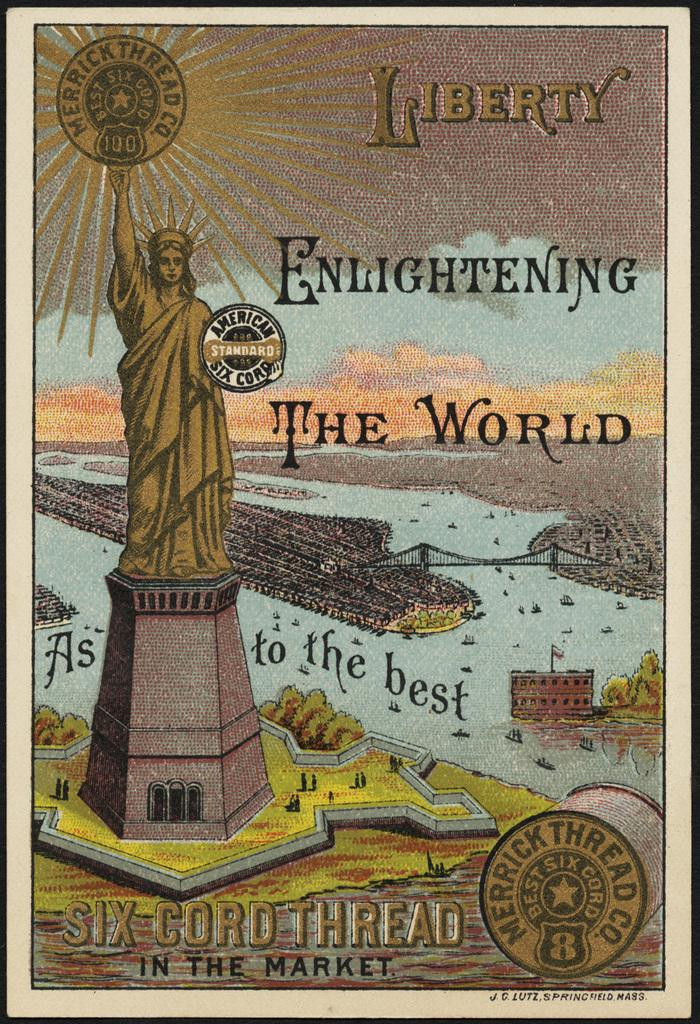<image>
Create a compact narrative representing the image presented. A poster of the statue of liberty holding a sign that says American Standard Six Corp. 